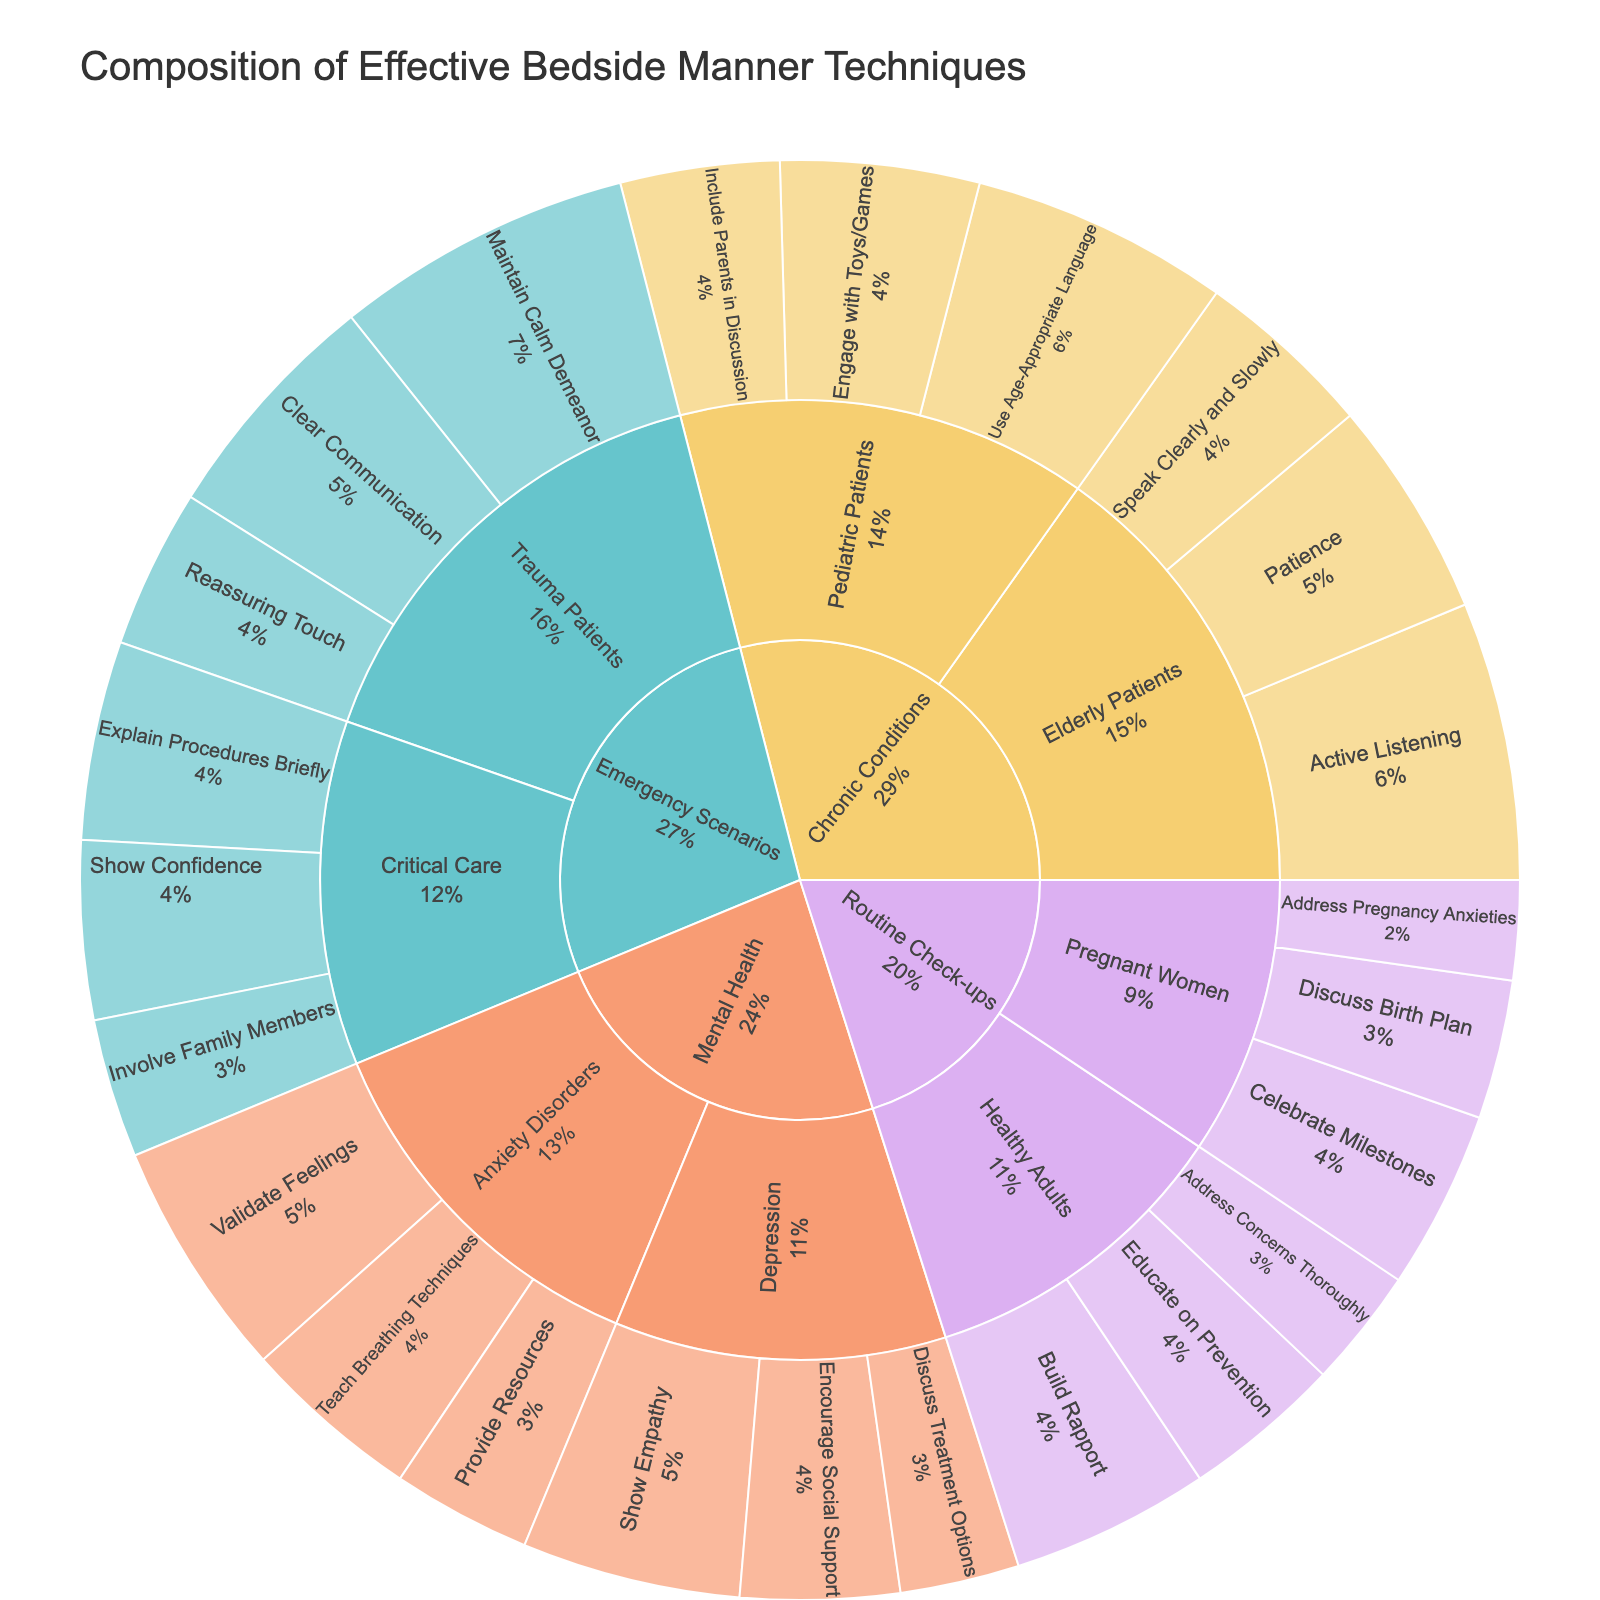what is the title of the figure? The title is clearly displayed at the top of the figure within a prominent position.
Answer: Composition of Effective Bedside Manner Techniques How many techniques are identified for Trauma Patients in emergency scenarios? Look at the subcategory 'Trauma Patients' within the 'Emergency Scenarios' category and count each technique listed.
Answer: 3 Which category has the highest total value for its techniques combined? Calculate the total values for each category by summing up the values of all techniques within each category. The category with the highest total is the answer.
Answer: Chronic Conditions What is the sum of values for techniques used with Elderly Patients? Identify the techniques listed under 'Elderly Patients' and sum their values: Active Listening (14), Patience (11), and Speak Clearly and Slowly (9). The sum is 14 + 11 + 9 = 34.
Answer: 34 Which technique for Pregnant Women has the lowest value? Within the 'Routine Check-ups' category, find the 'Pregnant Women' subcategory and identify the technique with the lowest associated value.
Answer: Address Pregnancy Anxieties How does the number of techniques for Critical Care patients compare with those for Anxiety Disorders? Count the techniques listed under 'Critical Care' and compare with those under 'Anxiety Disorders'. Critical Care has 3 techniques while Anxiety Disorders also have 3.
Answer: Equal What percentage of the total value does the technique “Maintain Calm Demeanor” for Trauma Patients constitute in its subcategory? Calculate the percentage by dividing the value of “Maintain Calm Demeanor” (15) by the total value of all techniques in the 'Trauma Patients' subcategory (15+12+8). The percentage is (15/35)*100 ≈ 42.9%.
Answer: Approximately 42.9% Which subcategory under Mental Health has a higher total value for its techniques? Add up the values for techniques within each subcategory of Mental Health. Anxiety Disorders have (12 + 9 + 7 = 28) and Depression has (11 + 8 + 6 = 25). Anxiety Disorders have a higher total value.
Answer: Anxiety Disorders How many techniques are used for Critical Care patients in emergency scenarios? Locate the 'Critical Care' subcategory under 'Emergency Scenarios' and count all listed techniques.
Answer: 3 What is the average value of techniques for Pediatric Patients under Chronic Conditions? Add the values of all techniques for 'Pediatric Patients' (13, 10, 8) and divide by the number of techniques. The average is (13 + 10 + 8) / 3 = 31 / 3 ≈ 10.33.
Answer: Approximately 10.33 